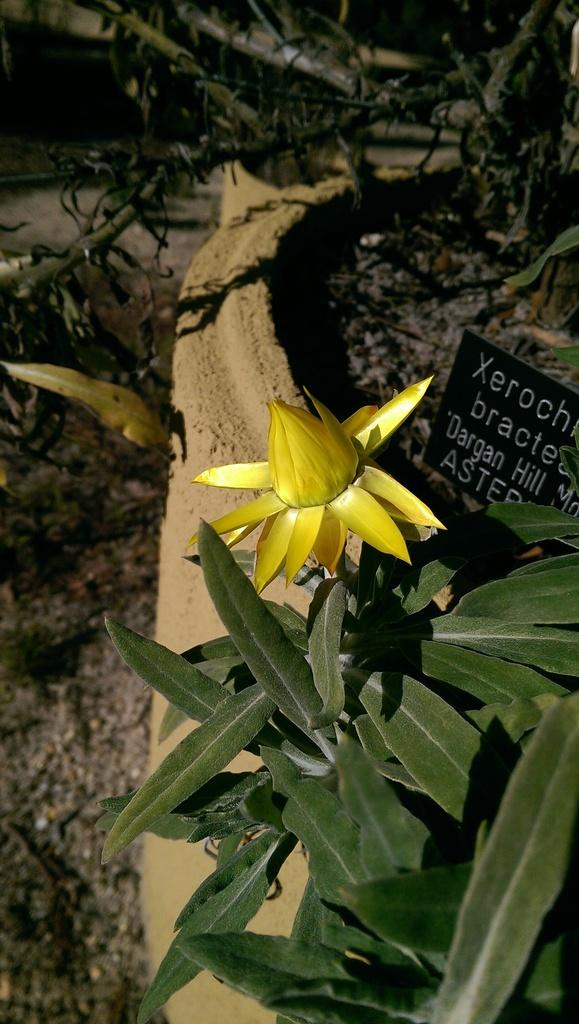What type of plant is visible in the image? There is a plant with a yellow flower in the image. What can be seen in the background of the image? There is a small name board and plants in the background of the image. What is visible on the ground in the image? The ground is visible in the background of the image. What type of plastic is used to make the committee's chairs in the image? There is no committee or chairs present in the image; it features a plant with a yellow flower and a background with a name board and additional plants. 